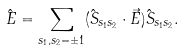<formula> <loc_0><loc_0><loc_500><loc_500>\hat { E } = \sum _ { s _ { 1 } , s _ { 2 } = \pm 1 } ( \hat { S } _ { s _ { 1 } s _ { 2 } } \cdot \vec { E } ) \hat { S } _ { s _ { 1 } s _ { 2 } } .</formula> 